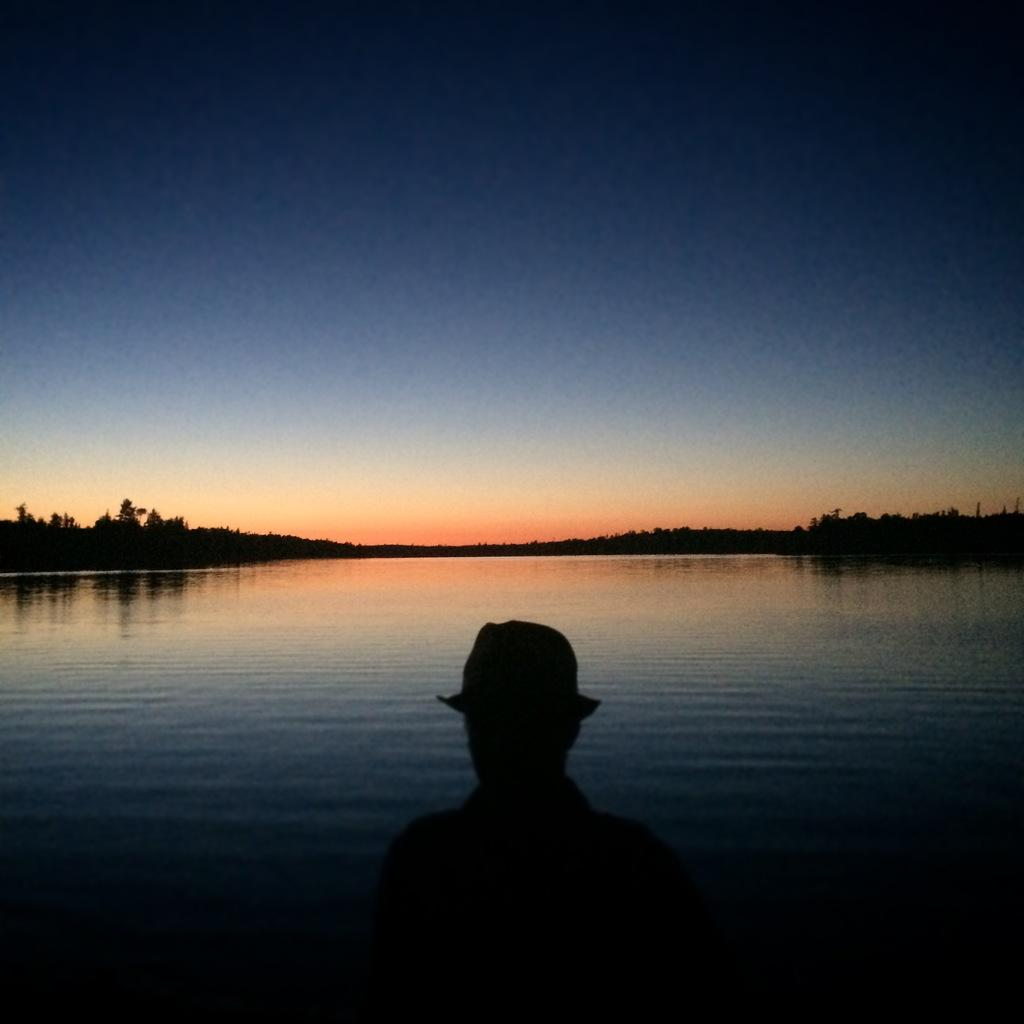Who or what is at the bottom of the image? There is a person at the bottom of the image. What is the primary element visible in the image? Water is visible in the image. What type of vegetation can be seen in the image? There are trees in the image. What is visible in the background of the image? The sky is visible in the background of the image. What type of butter is being used to paint the trees in the image? There is no butter or painting activity present in the image; it features a person, water, trees, and the sky. 